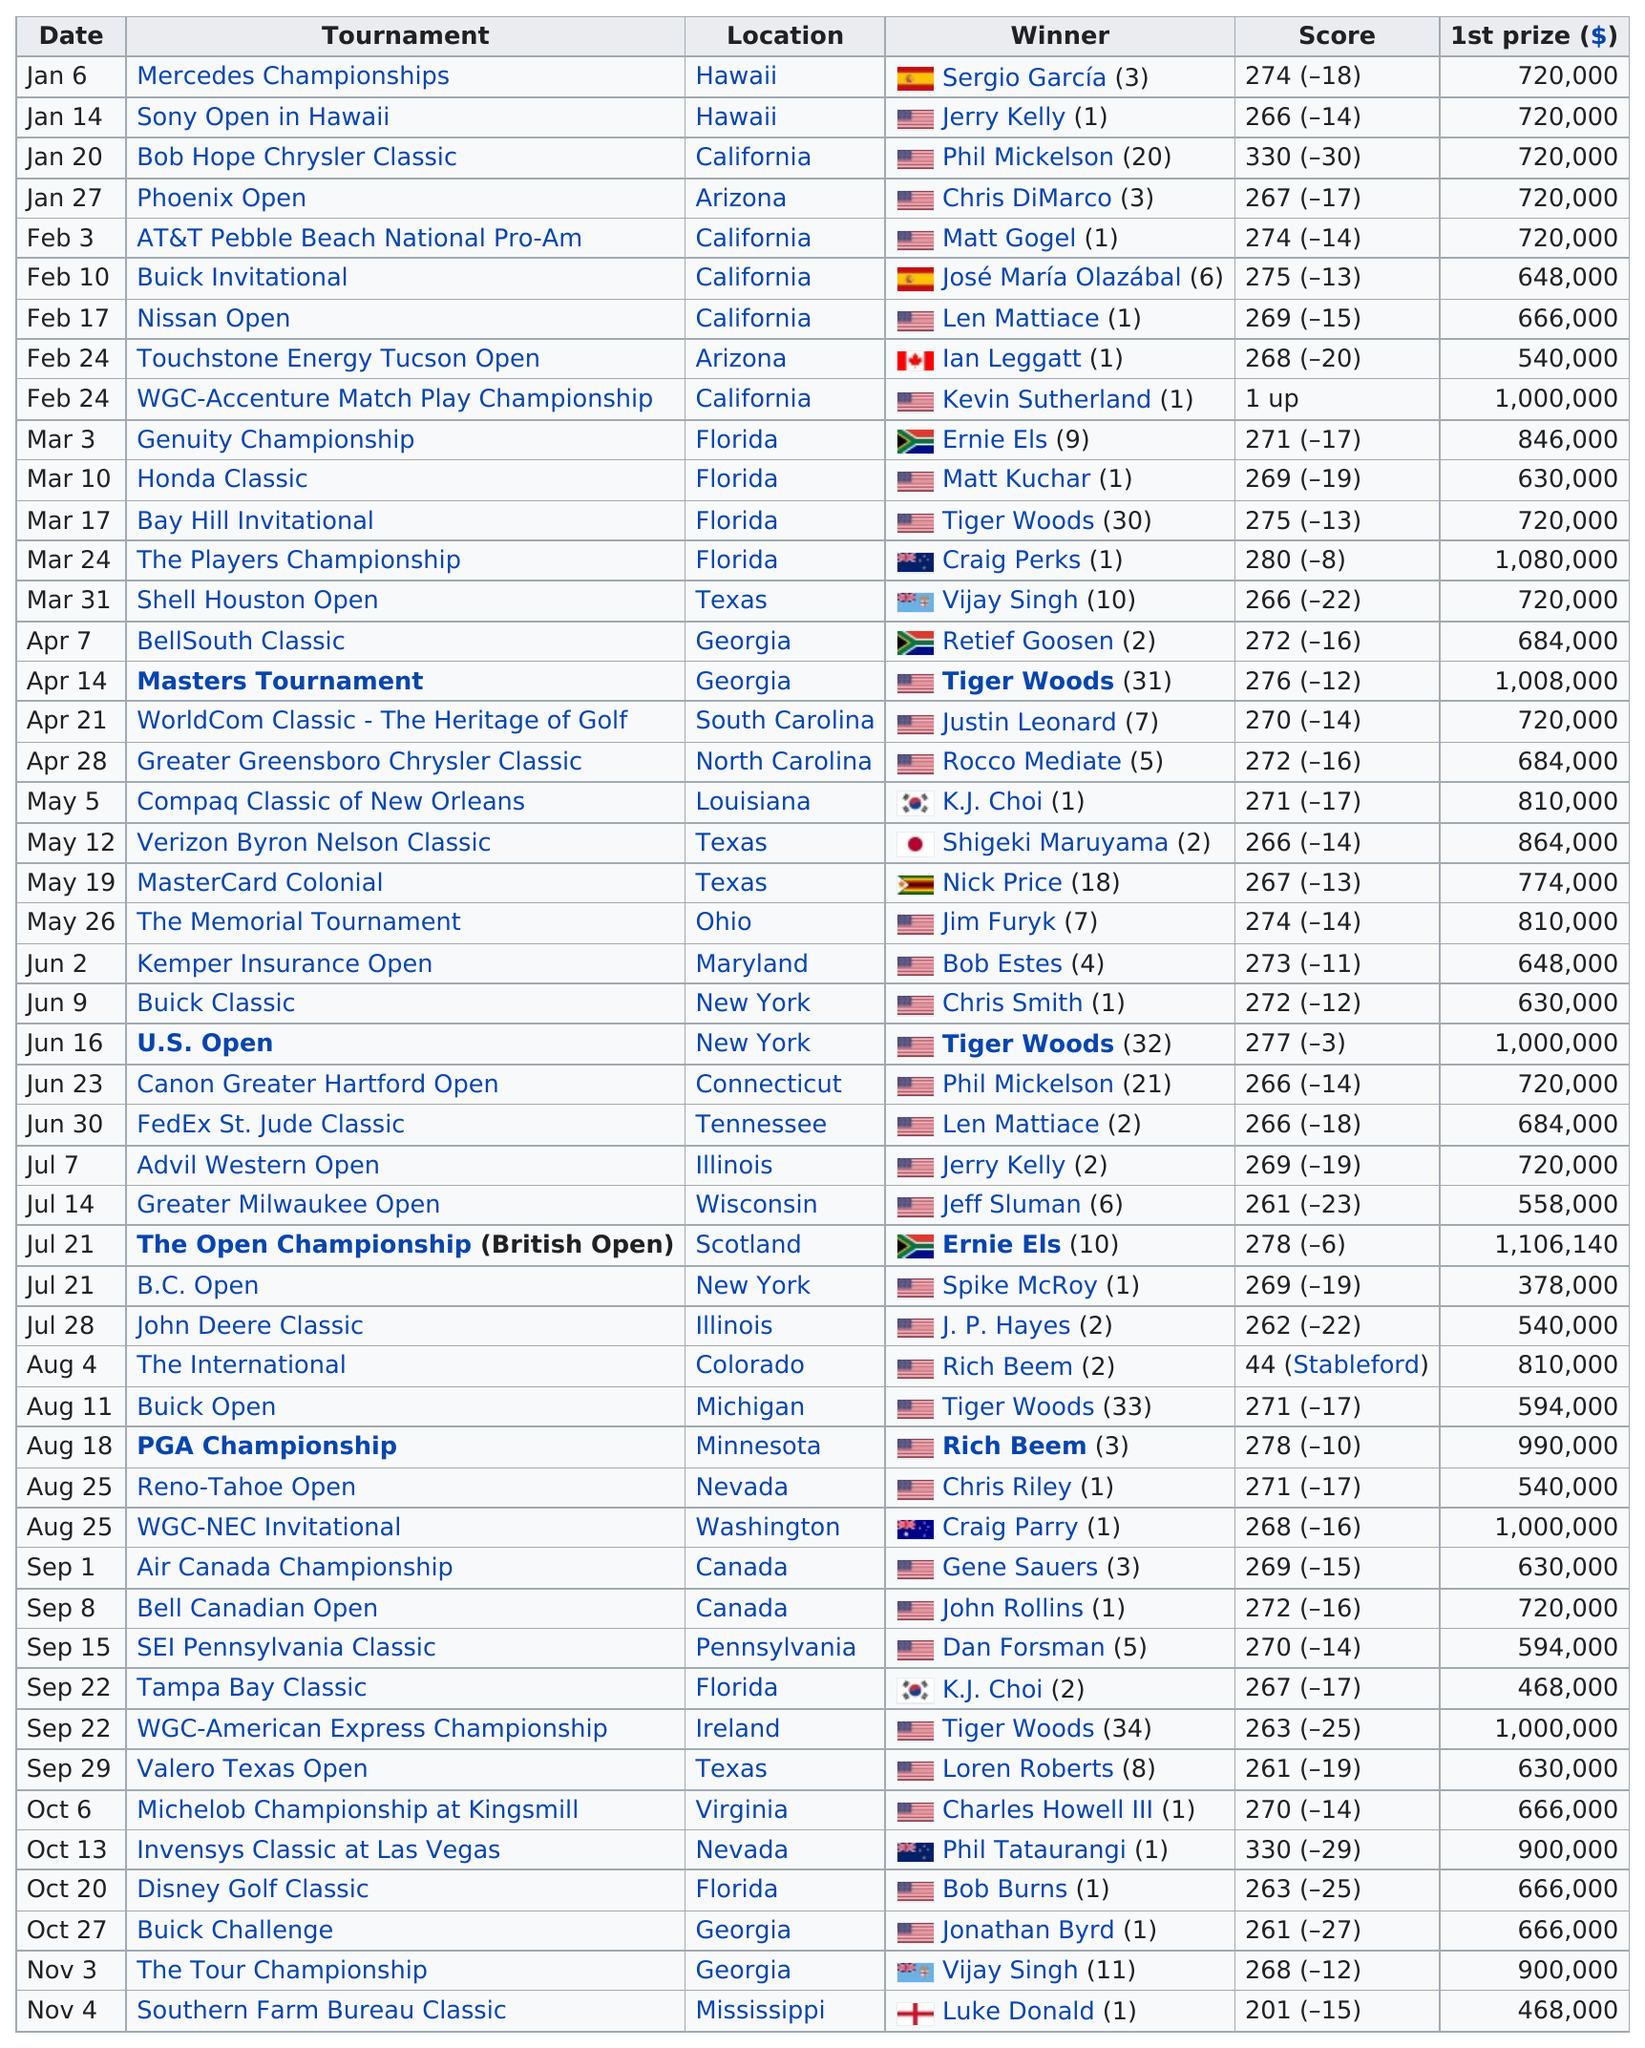Outline some significant characteristics in this image. Chris Riley, a player, won his/her first game at the Reno-Tahoe Open, which took place recently. Phil Mickelson's score at the Bob Hope Chrysler Classic was lower than Chris Smith's score at the Buick Classic, resulting in a difference of 58. It is confirmed that Luke Donald is the winner of the most recent PGA Tour event of the year. The Mercedes Championships and Sony Open in Hawaii are both held in the state of Hawaii. The B.C. Open provided the lowest amount of prize money to its first-place finisher among all PGA Tour events. 